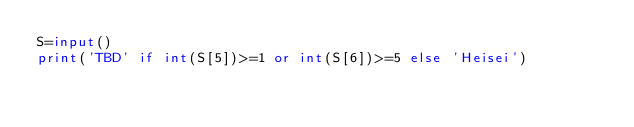Convert code to text. <code><loc_0><loc_0><loc_500><loc_500><_Python_>S=input()
print('TBD' if int(S[5])>=1 or int(S[6])>=5 else 'Heisei')
</code> 